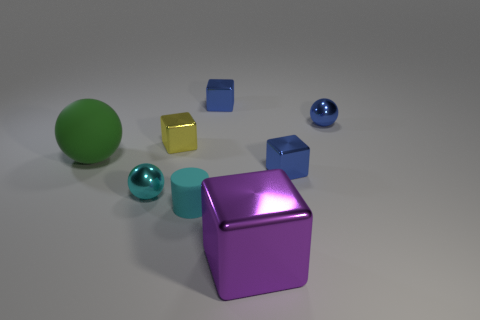Subtract all small balls. How many balls are left? 1 Subtract all gray cylinders. How many blue blocks are left? 2 Subtract all yellow blocks. How many blocks are left? 3 Add 2 shiny objects. How many objects exist? 10 Subtract all brown blocks. Subtract all gray cylinders. How many blocks are left? 4 Subtract all cylinders. How many objects are left? 7 Add 4 large metal objects. How many large metal objects are left? 5 Add 6 small blue blocks. How many small blue blocks exist? 8 Subtract 1 cyan spheres. How many objects are left? 7 Subtract all big blue metallic cubes. Subtract all cyan shiny objects. How many objects are left? 7 